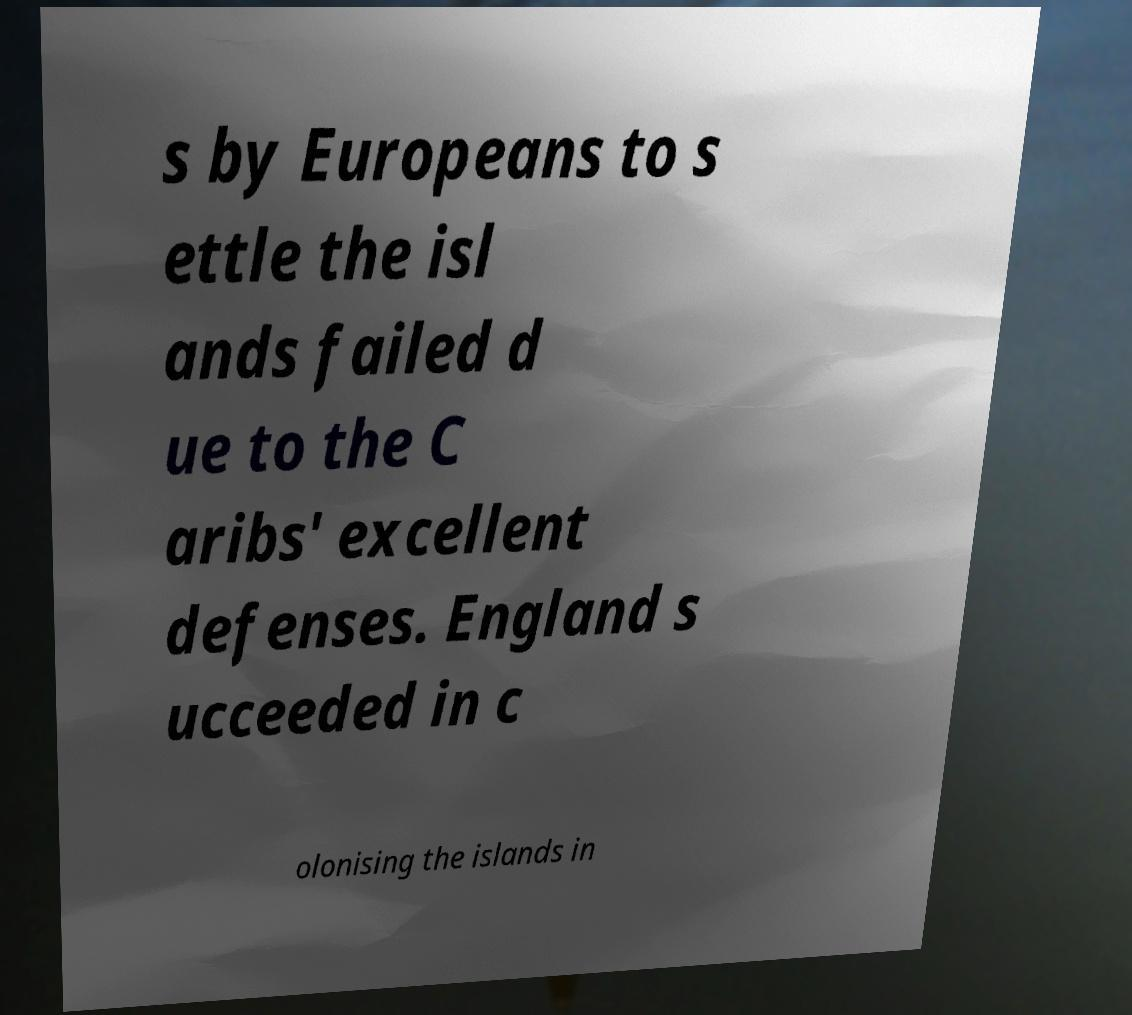There's text embedded in this image that I need extracted. Can you transcribe it verbatim? s by Europeans to s ettle the isl ands failed d ue to the C aribs' excellent defenses. England s ucceeded in c olonising the islands in 